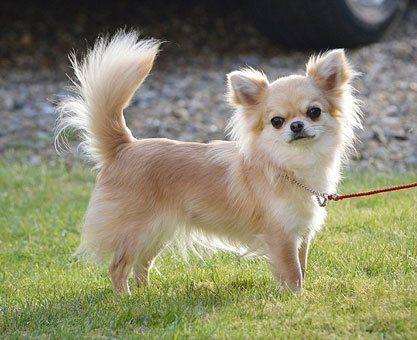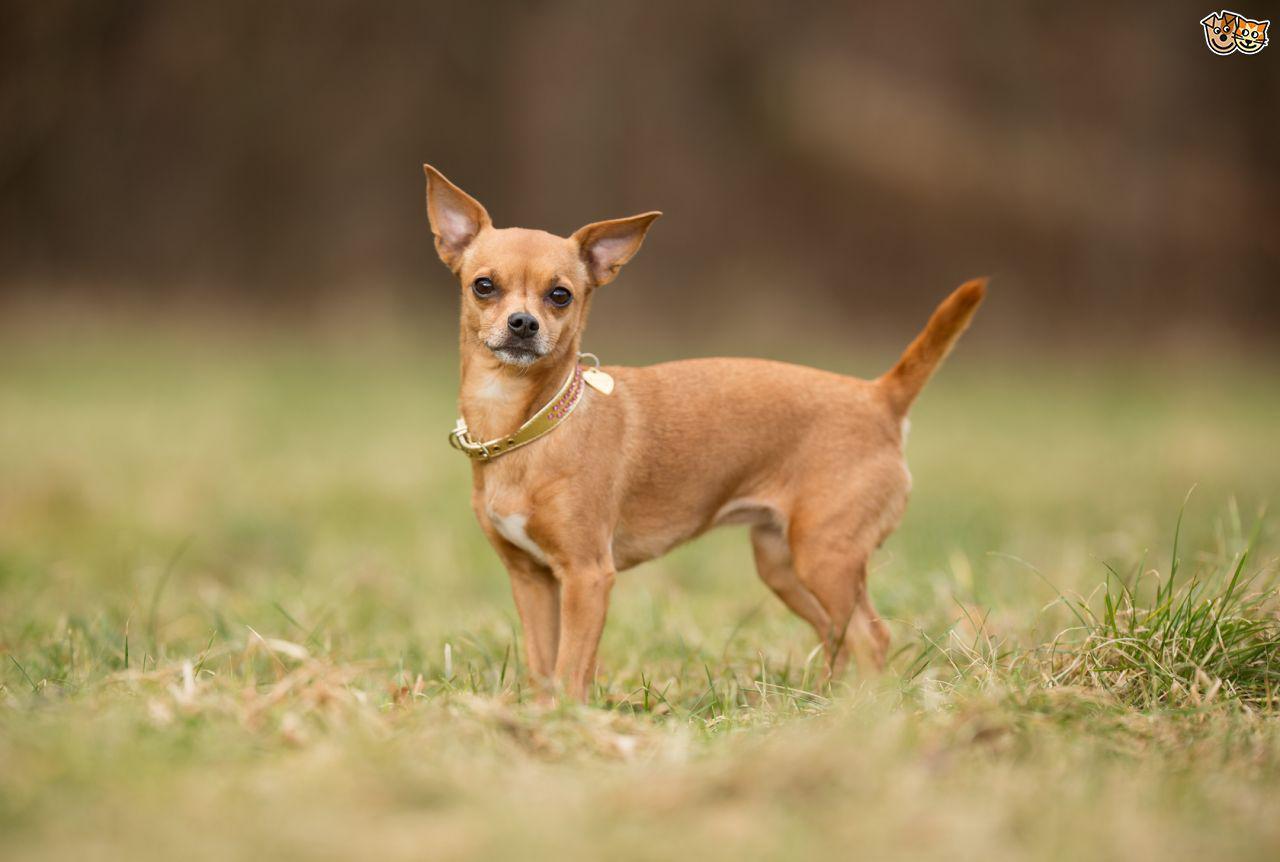The first image is the image on the left, the second image is the image on the right. Evaluate the accuracy of this statement regarding the images: "One image shows a dog on a leash and the other shows a dog by white fabric.". Is it true? Answer yes or no. No. 